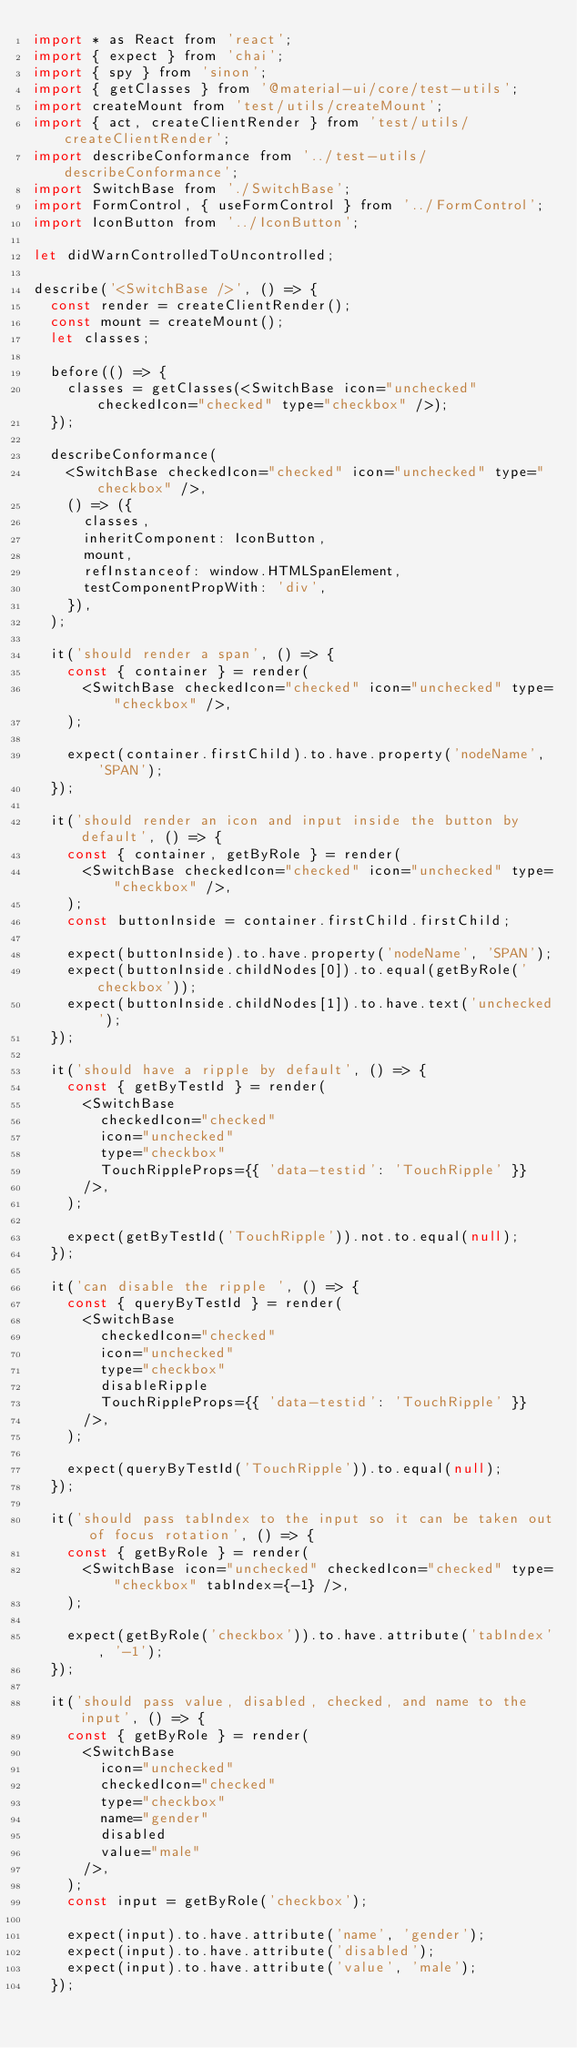<code> <loc_0><loc_0><loc_500><loc_500><_JavaScript_>import * as React from 'react';
import { expect } from 'chai';
import { spy } from 'sinon';
import { getClasses } from '@material-ui/core/test-utils';
import createMount from 'test/utils/createMount';
import { act, createClientRender } from 'test/utils/createClientRender';
import describeConformance from '../test-utils/describeConformance';
import SwitchBase from './SwitchBase';
import FormControl, { useFormControl } from '../FormControl';
import IconButton from '../IconButton';

let didWarnControlledToUncontrolled;

describe('<SwitchBase />', () => {
  const render = createClientRender();
  const mount = createMount();
  let classes;

  before(() => {
    classes = getClasses(<SwitchBase icon="unchecked" checkedIcon="checked" type="checkbox" />);
  });

  describeConformance(
    <SwitchBase checkedIcon="checked" icon="unchecked" type="checkbox" />,
    () => ({
      classes,
      inheritComponent: IconButton,
      mount,
      refInstanceof: window.HTMLSpanElement,
      testComponentPropWith: 'div',
    }),
  );

  it('should render a span', () => {
    const { container } = render(
      <SwitchBase checkedIcon="checked" icon="unchecked" type="checkbox" />,
    );

    expect(container.firstChild).to.have.property('nodeName', 'SPAN');
  });

  it('should render an icon and input inside the button by default', () => {
    const { container, getByRole } = render(
      <SwitchBase checkedIcon="checked" icon="unchecked" type="checkbox" />,
    );
    const buttonInside = container.firstChild.firstChild;

    expect(buttonInside).to.have.property('nodeName', 'SPAN');
    expect(buttonInside.childNodes[0]).to.equal(getByRole('checkbox'));
    expect(buttonInside.childNodes[1]).to.have.text('unchecked');
  });

  it('should have a ripple by default', () => {
    const { getByTestId } = render(
      <SwitchBase
        checkedIcon="checked"
        icon="unchecked"
        type="checkbox"
        TouchRippleProps={{ 'data-testid': 'TouchRipple' }}
      />,
    );

    expect(getByTestId('TouchRipple')).not.to.equal(null);
  });

  it('can disable the ripple ', () => {
    const { queryByTestId } = render(
      <SwitchBase
        checkedIcon="checked"
        icon="unchecked"
        type="checkbox"
        disableRipple
        TouchRippleProps={{ 'data-testid': 'TouchRipple' }}
      />,
    );

    expect(queryByTestId('TouchRipple')).to.equal(null);
  });

  it('should pass tabIndex to the input so it can be taken out of focus rotation', () => {
    const { getByRole } = render(
      <SwitchBase icon="unchecked" checkedIcon="checked" type="checkbox" tabIndex={-1} />,
    );

    expect(getByRole('checkbox')).to.have.attribute('tabIndex', '-1');
  });

  it('should pass value, disabled, checked, and name to the input', () => {
    const { getByRole } = render(
      <SwitchBase
        icon="unchecked"
        checkedIcon="checked"
        type="checkbox"
        name="gender"
        disabled
        value="male"
      />,
    );
    const input = getByRole('checkbox');

    expect(input).to.have.attribute('name', 'gender');
    expect(input).to.have.attribute('disabled');
    expect(input).to.have.attribute('value', 'male');
  });
</code> 